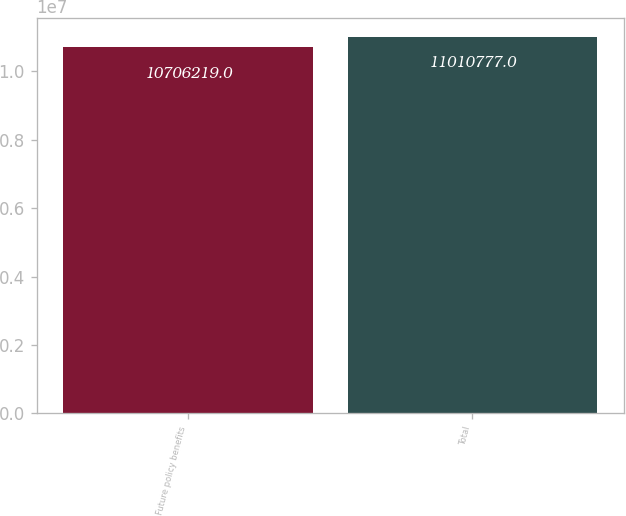Convert chart to OTSL. <chart><loc_0><loc_0><loc_500><loc_500><bar_chart><fcel>Future policy benefits<fcel>Total<nl><fcel>1.07062e+07<fcel>1.10108e+07<nl></chart> 